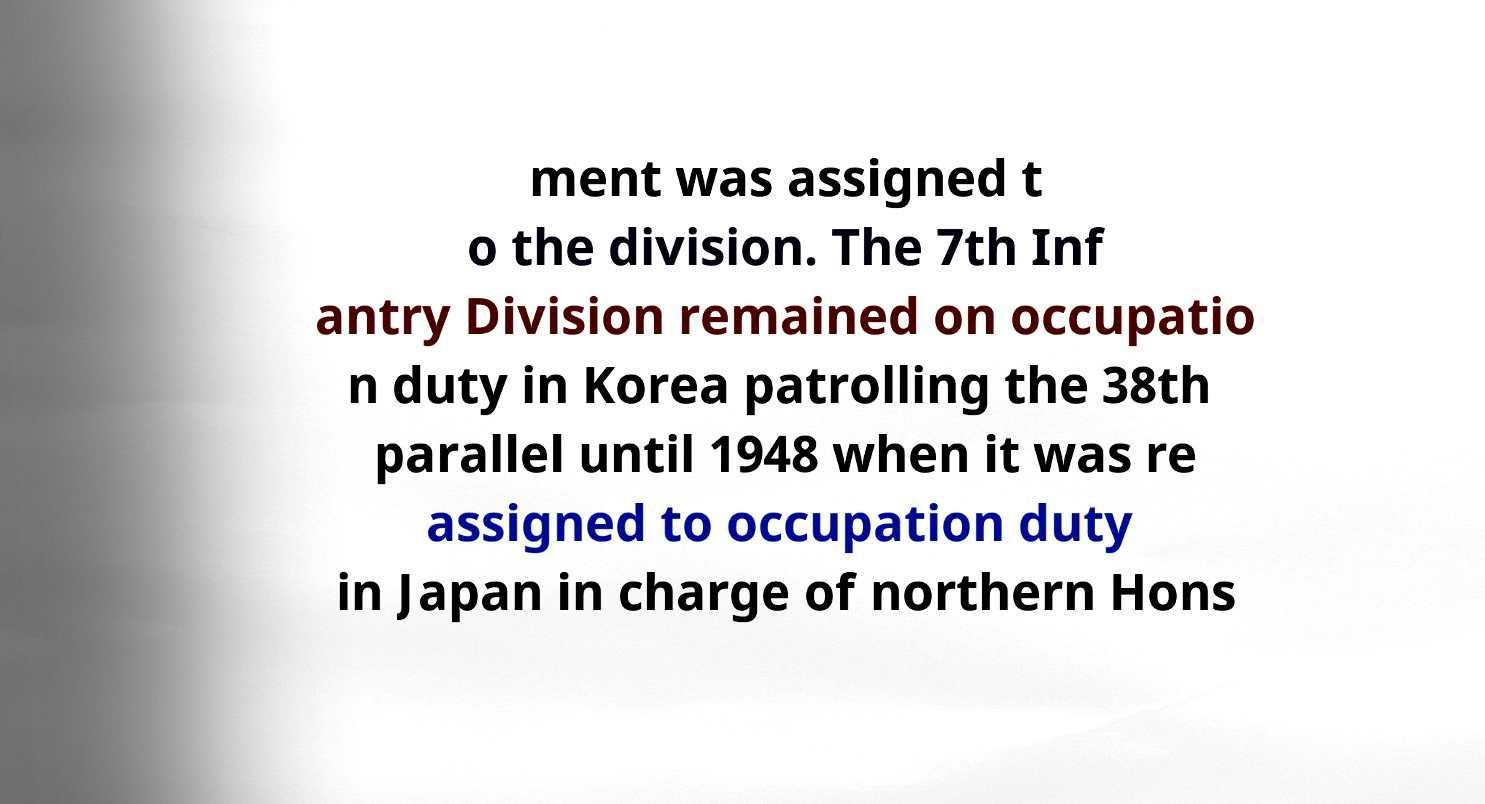Could you assist in decoding the text presented in this image and type it out clearly? ment was assigned t o the division. The 7th Inf antry Division remained on occupatio n duty in Korea patrolling the 38th parallel until 1948 when it was re assigned to occupation duty in Japan in charge of northern Hons 